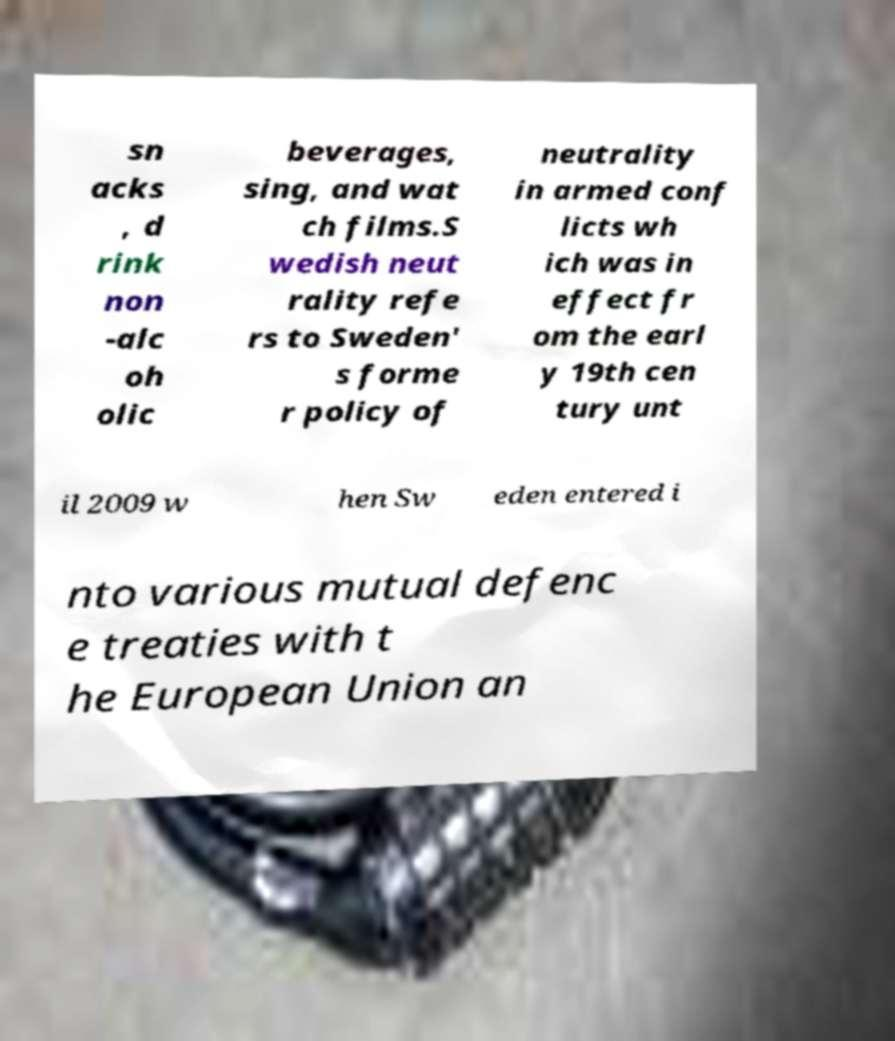I need the written content from this picture converted into text. Can you do that? sn acks , d rink non -alc oh olic beverages, sing, and wat ch films.S wedish neut rality refe rs to Sweden' s forme r policy of neutrality in armed conf licts wh ich was in effect fr om the earl y 19th cen tury unt il 2009 w hen Sw eden entered i nto various mutual defenc e treaties with t he European Union an 